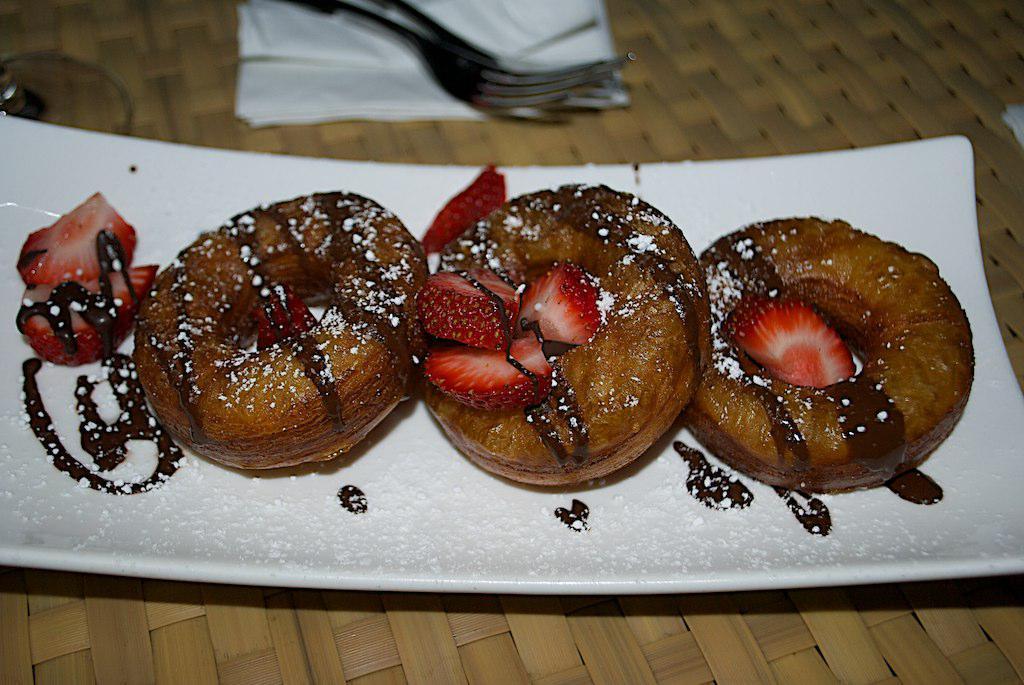Please provide a concise description of this image. In this image we can see a table and there is a plate, strawberries, donuts, forks and napkins placed on the table. 